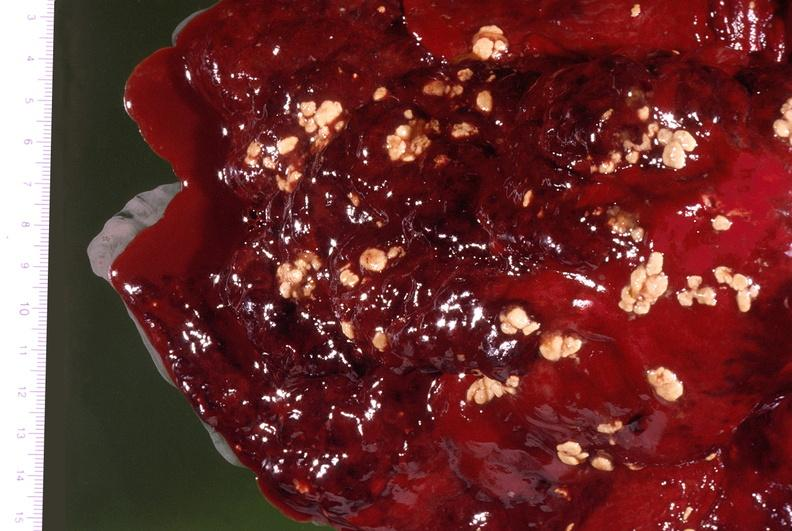where is this?
Answer the question using a single word or phrase. Lung 